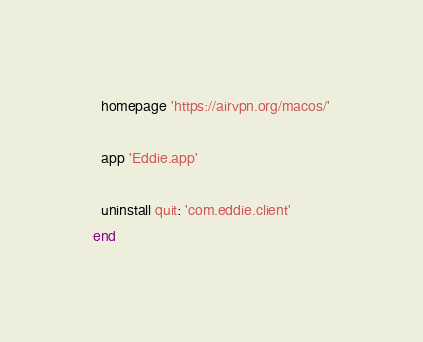<code> <loc_0><loc_0><loc_500><loc_500><_Ruby_>  homepage 'https://airvpn.org/macos/'

  app 'Eddie.app'

  uninstall quit: 'com.eddie.client'
end
</code> 